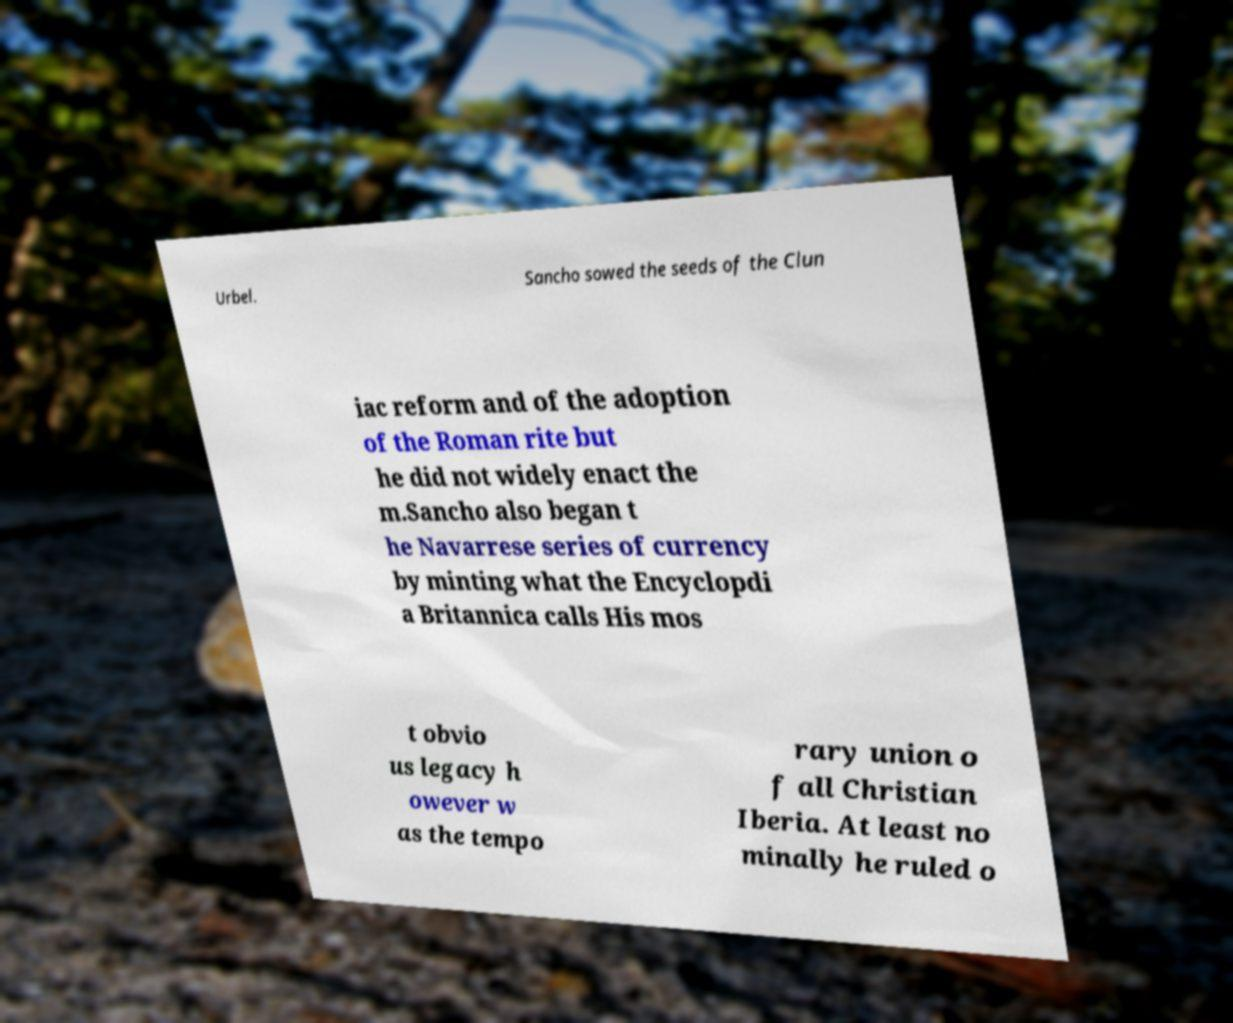Please read and relay the text visible in this image. What does it say? Urbel. Sancho sowed the seeds of the Clun iac reform and of the adoption of the Roman rite but he did not widely enact the m.Sancho also began t he Navarrese series of currency by minting what the Encyclopdi a Britannica calls His mos t obvio us legacy h owever w as the tempo rary union o f all Christian Iberia. At least no minally he ruled o 